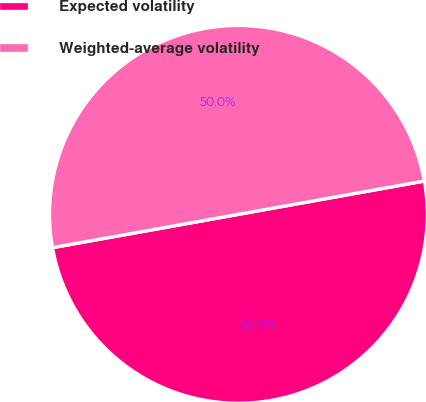Convert chart to OTSL. <chart><loc_0><loc_0><loc_500><loc_500><pie_chart><fcel>Expected volatility<fcel>Weighted-average volatility<nl><fcel>50.0%<fcel>50.0%<nl></chart> 